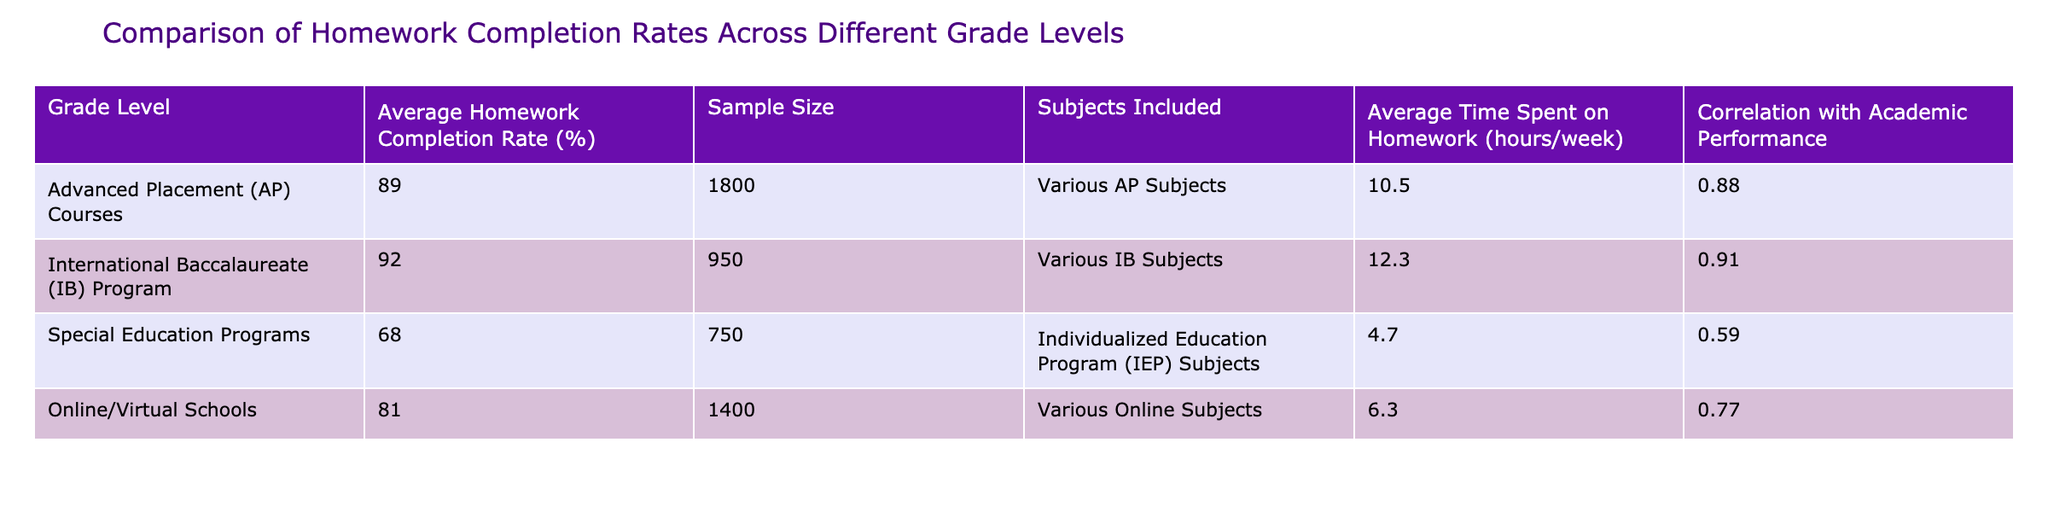What is the average homework completion rate for International Baccalaureate (IB) Program students? The table shows that the average homework completion rate for the IB Program is 92%.
Answer: 92% How many subjects are included for Advanced Placement (AP) Courses? The table indicates that the subjects included for AP Courses are labeled as "Various AP Subjects." Therefore, the specific number of subjects is not provided.
Answer: Not specified Is the homework completion rate for Special Education Programs higher than that for Online/Virtual Schools? The table shows that the completion rate for Special Education Programs is 68%, while for Online/Virtual Schools, it's 81%. Since 68 is less than 81, the statement is false.
Answer: No What is the correlation between homework completion and academic performance for students in AP Courses? According to the table, the correlation for AP Courses is 0.88.
Answer: 0.88 Calculate the average time spent on homework per week for all groups listed. To calculate the average, sum the average time spent on homework: (10.5 + 12.3 + 4.7 + 6.3) = 33.8 hours. Then divide by the number of groups (4): 33.8 / 4 = 8.45 hours.
Answer: 8.45 hours Which program has the highest sample size, and how many students are in that program? The table shows that the program with the highest sample size is Advanced Placement (AP) Courses, with a sample size of 1800 students.
Answer: Advanced Placement, 1800 If a new program had a completion rate of 85% with a sample size of 500, what would be the average completion rate if all programs are combined? To find the new average, sum all completion rates multiplied by their sample sizes, including the new program: (89*1800 + 92*950 + 68*750 + 81*1400 + 85*500) / (1800 + 950 + 750 + 1400 + 500) = (160200 + 87400 + 51000 + 113400 + 42500) / 4400 = 81.525.
Answer: 81.525% Is the average homework completion rate for students in the IB Program significantly higher than for students with Special Education Programs? The average completion rate for the IB Program is 92%, while for Special Education Programs it is 68%. The difference is significant because 92 is much greater than 68.
Answer: Yes What is the average homework completion rate across all grade levels listed? To find the average, sum the completion rates (89 + 92 + 68 + 81) = 330 and divide by the number of grade levels (4): 330 / 4 = 82.5.
Answer: 82.5% 